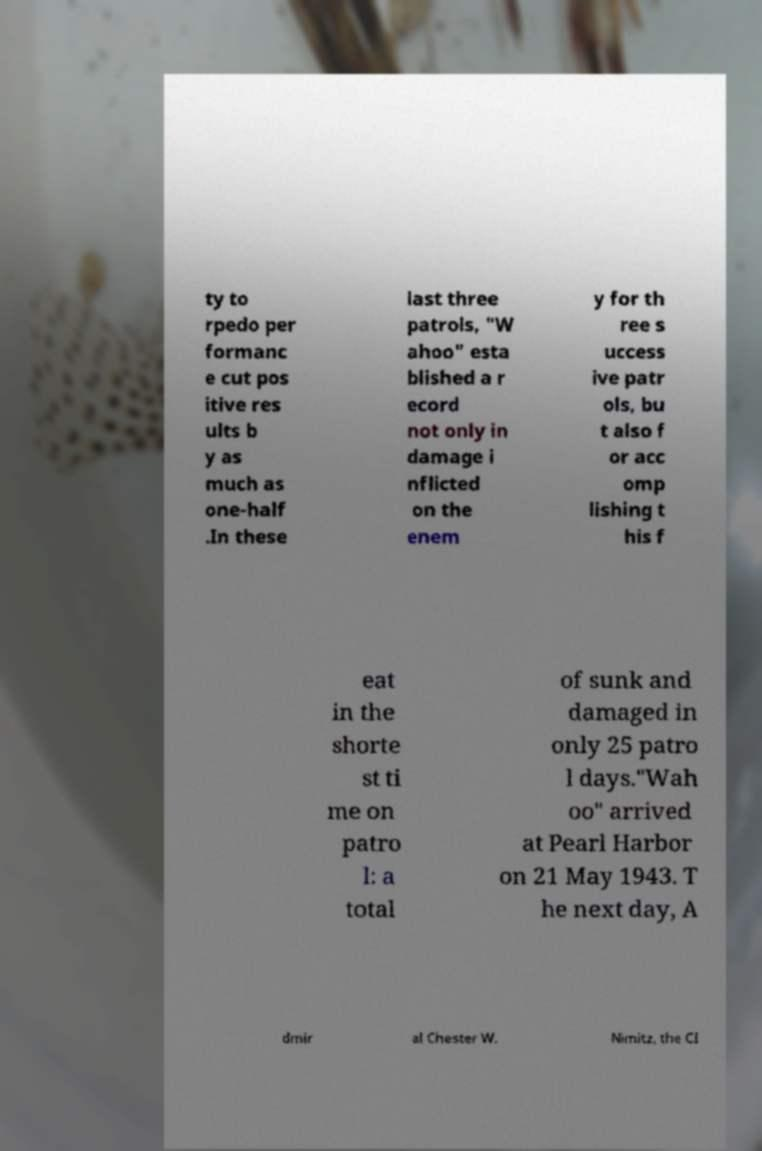Can you read and provide the text displayed in the image?This photo seems to have some interesting text. Can you extract and type it out for me? ty to rpedo per formanc e cut pos itive res ults b y as much as one-half .In these last three patrols, "W ahoo" esta blished a r ecord not only in damage i nflicted on the enem y for th ree s uccess ive patr ols, bu t also f or acc omp lishing t his f eat in the shorte st ti me on patro l: a total of sunk and damaged in only 25 patro l days."Wah oo" arrived at Pearl Harbor on 21 May 1943. T he next day, A dmir al Chester W. Nimitz, the CI 